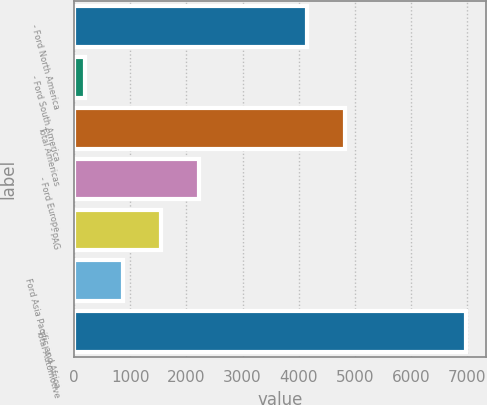Convert chart. <chart><loc_0><loc_0><loc_500><loc_500><bar_chart><fcel>- Ford North America<fcel>- Ford South America<fcel>Total Americas<fcel>- Ford Europe<fcel>- PAG<fcel>Ford Asia Pacific and Africa<fcel>Total Automotive<nl><fcel>4146<fcel>195<fcel>4823.8<fcel>2228.4<fcel>1550.6<fcel>872.8<fcel>6973<nl></chart> 